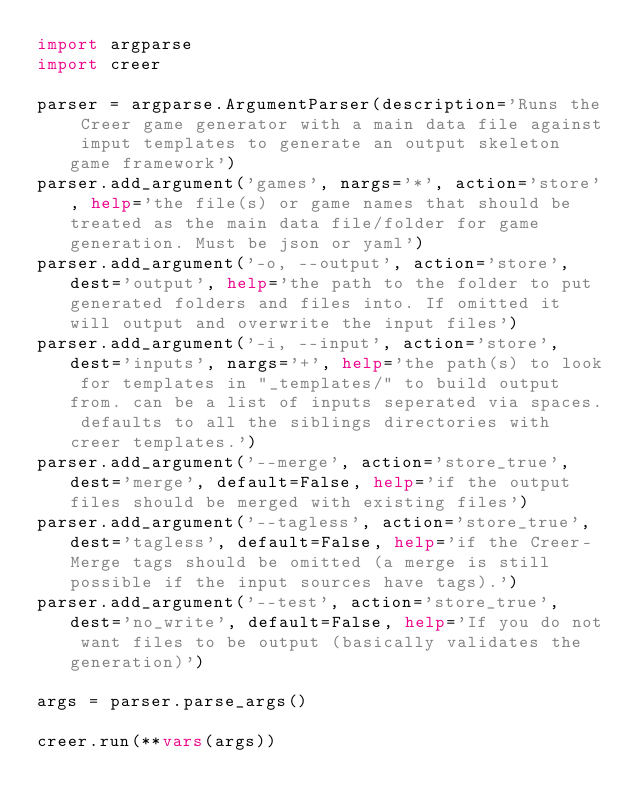Convert code to text. <code><loc_0><loc_0><loc_500><loc_500><_Python_>import argparse
import creer

parser = argparse.ArgumentParser(description='Runs the Creer game generator with a main data file against imput templates to generate an output skeleton game framework')
parser.add_argument('games', nargs='*', action='store', help='the file(s) or game names that should be treated as the main data file/folder for game generation. Must be json or yaml')
parser.add_argument('-o, --output', action='store', dest='output', help='the path to the folder to put generated folders and files into. If omitted it will output and overwrite the input files')
parser.add_argument('-i, --input', action='store', dest='inputs', nargs='+', help='the path(s) to look for templates in "_templates/" to build output from. can be a list of inputs seperated via spaces. defaults to all the siblings directories with creer templates.')
parser.add_argument('--merge', action='store_true', dest='merge', default=False, help='if the output files should be merged with existing files')
parser.add_argument('--tagless', action='store_true', dest='tagless', default=False, help='if the Creer-Merge tags should be omitted (a merge is still possible if the input sources have tags).')
parser.add_argument('--test', action='store_true', dest='no_write', default=False, help='If you do not want files to be output (basically validates the generation)')

args = parser.parse_args()

creer.run(**vars(args))
</code> 